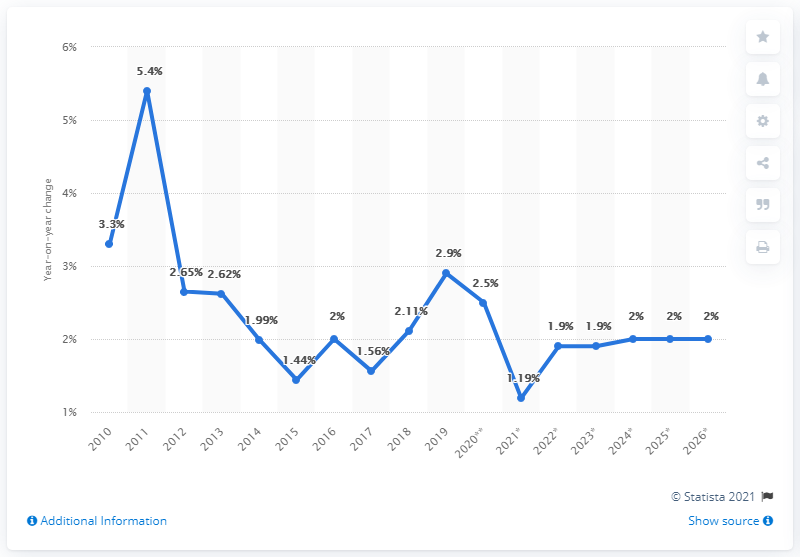Draw attention to some important aspects in this diagram. In 2011, the inflation rate reached its highest point. The inflation rate difference between 2011 and 2012 was greater than the difference between 2019 and 2021. 